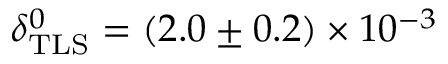Convert formula to latex. <formula><loc_0><loc_0><loc_500><loc_500>\delta _ { T L S } ^ { 0 } = ( 2 . 0 \pm 0 . 2 ) \times 1 0 ^ { - 3 }</formula> 